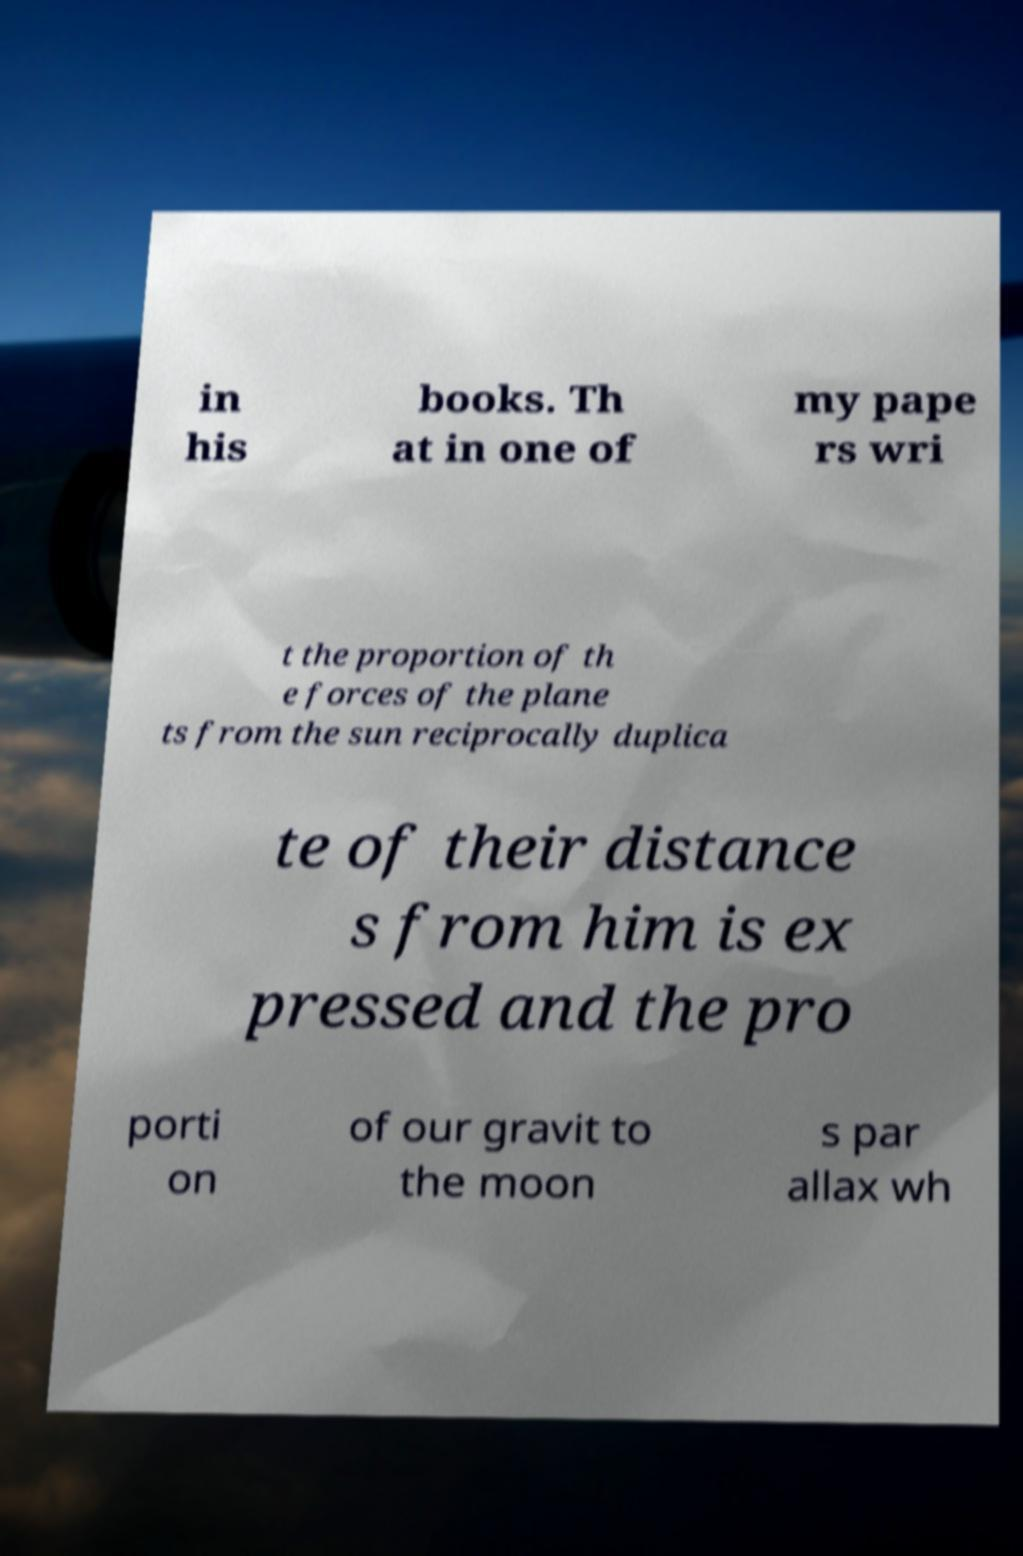Could you assist in decoding the text presented in this image and type it out clearly? in his books. Th at in one of my pape rs wri t the proportion of th e forces of the plane ts from the sun reciprocally duplica te of their distance s from him is ex pressed and the pro porti on of our gravit to the moon s par allax wh 